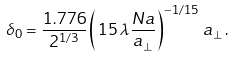<formula> <loc_0><loc_0><loc_500><loc_500>\delta _ { 0 } = \frac { 1 . 7 7 6 } { 2 ^ { 1 / 3 } } \left ( \, 1 5 \, \lambda \frac { N a } { a _ { \perp } } \right ) ^ { - 1 / 1 5 } \, a _ { \perp } \, .</formula> 